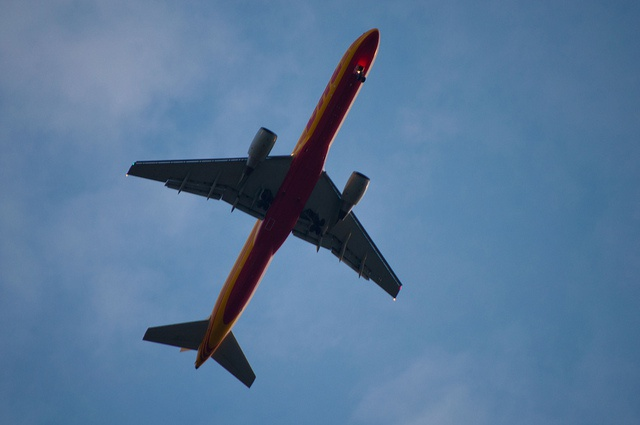Describe the objects in this image and their specific colors. I can see a airplane in gray, black, and maroon tones in this image. 